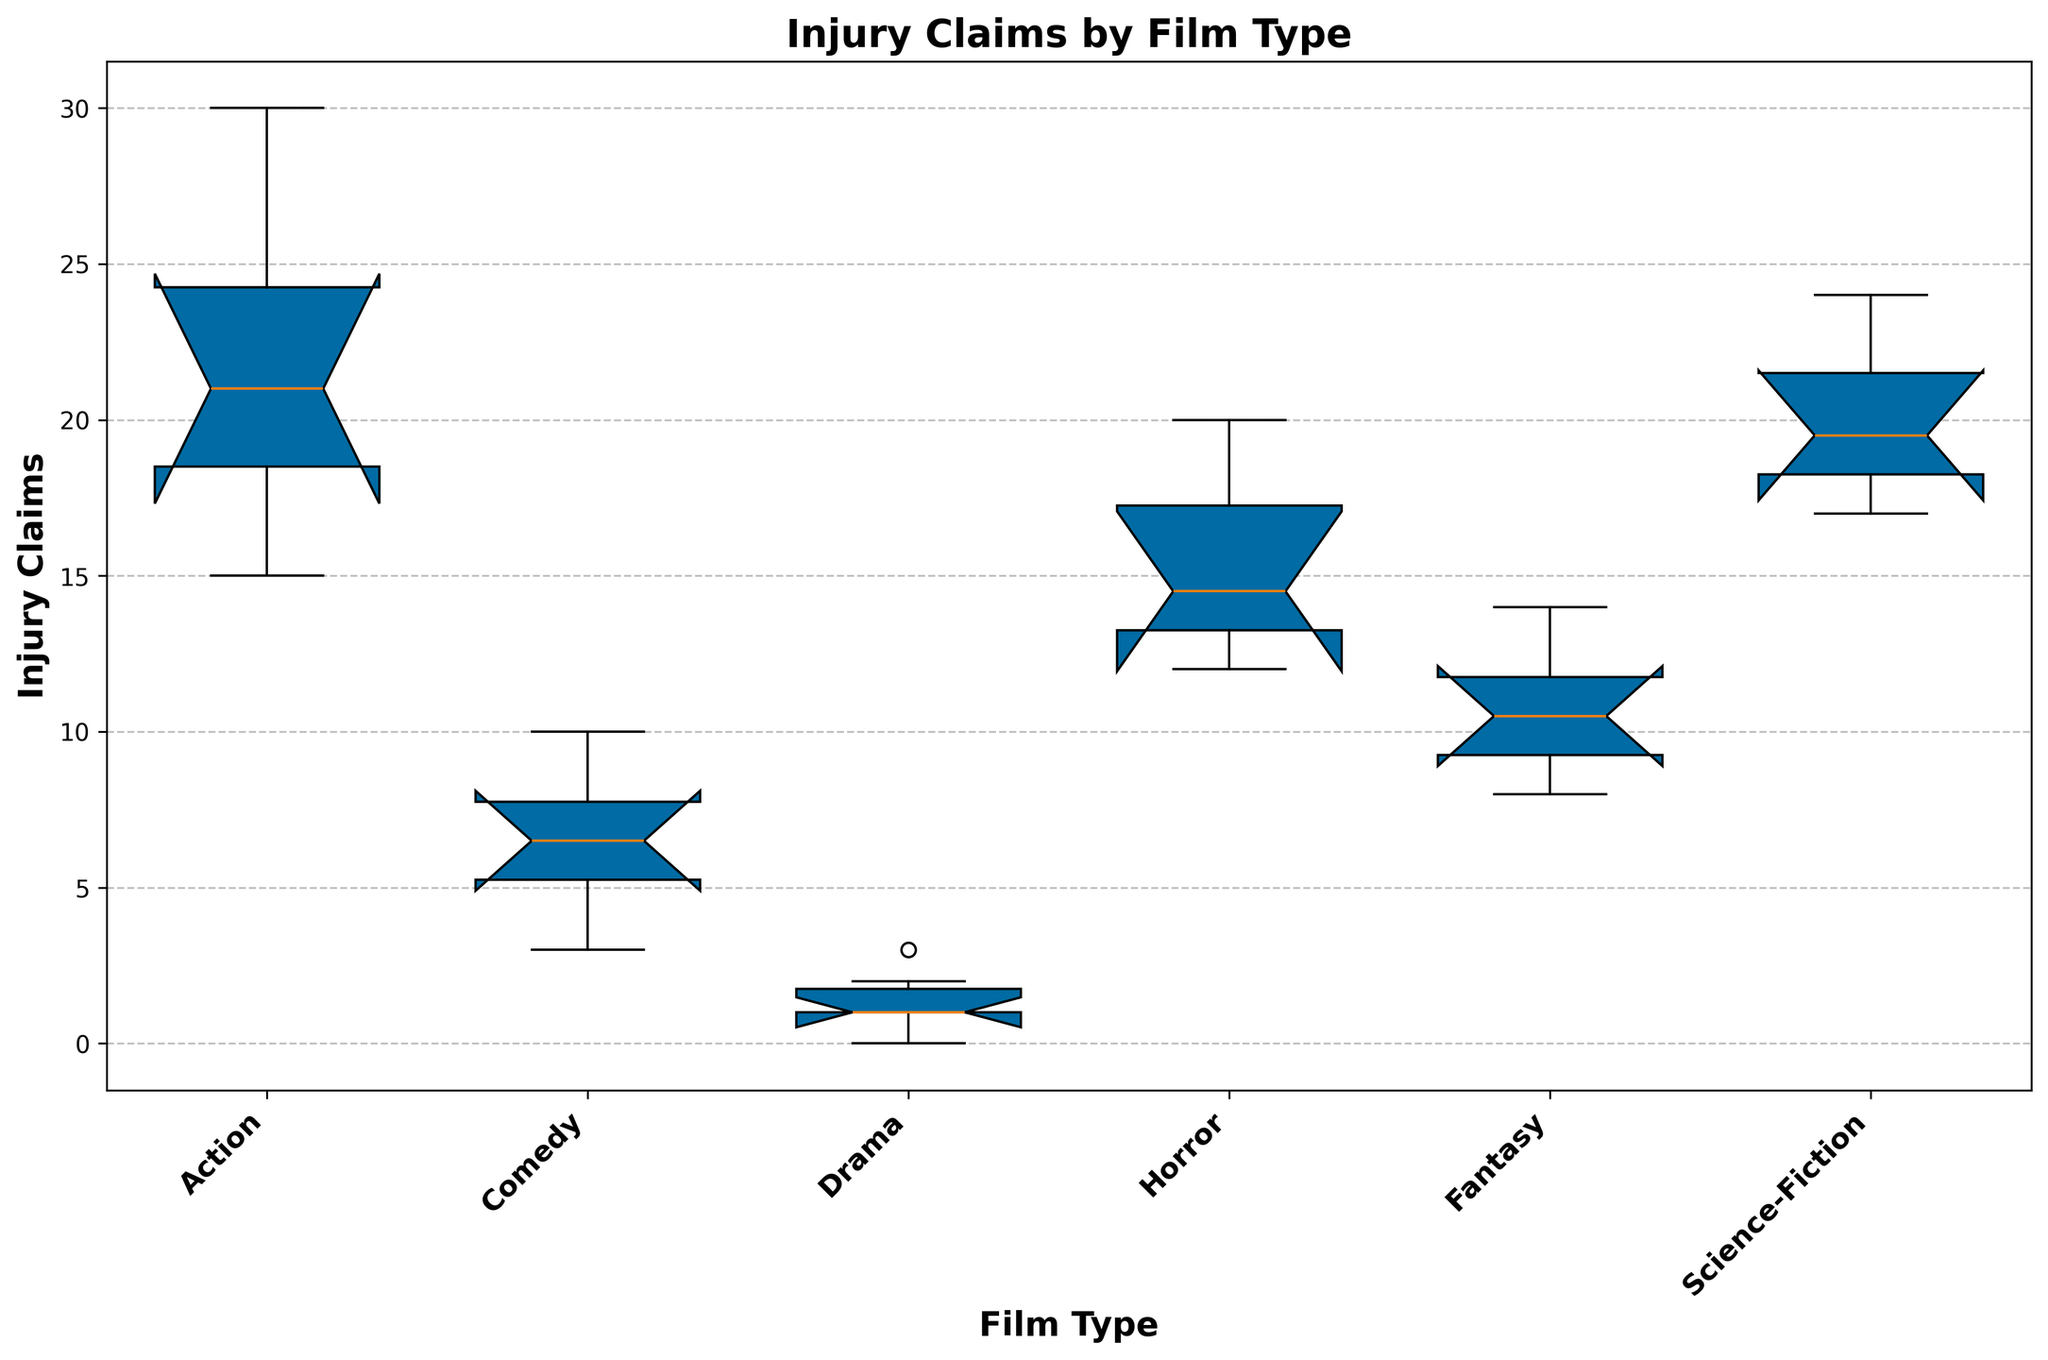what's the median value of Injury Claims for Horror films? To find the median value of Injury Claims for Horror films, look at the middle value when the injury claims data for Horror films is sorted. The values are 12, 13, 14, 15, 18, 20. The median is the average of the two middle values (14 and 15), which is (14+15)/2 = 14.5.
Answer: 14.5 Which film type has the highest median value of injury claims? To answer this, compare the median values of injury claims for all film types. The film type with the highest median is Action, with a median around 20.
Answer: Action Which film type has the lowest median value of injury claims? To determine the film type with the lowest median, look at the box plots and identify the film type with the lowest median line. Drama has the lowest median, with a median around 1.
Answer: Drama How does the interquartile range (IQR) of injury claims for Action films compare to that of Comedy films? To compare the IQR of Action and Comedy films, observe the length of the boxes for each. The IQR of Action films is the distance between the first and third quartiles and is significantly larger than the IQR for Comedy films. Therefore, Action films have a larger IQR for injury claims than Comedy films.
Answer: Larger Are there any outliers in the injury claims data for Science-Fiction films? To identify outliers, look for points that fall outside the whiskers of the box plot for Science-Fiction films. There do not appear to be any distinct outliers beyond the whiskers for Science-Fiction films.
Answer: No Which film type has the widest range of injury claims? To find the film type with the widest range, examine the whiskers (lines extending from the boxes) and pick the one with the longest extension. Action films display the widest range.
Answer: Action Compare the third quartile (Q3) of injury claims between Fantasy and Horror films. The third quartile (Q3) is the top edge of each box. For Fantasy films, Q3 is around 12. For Horror films, Q3 is around 18. Horror films have a higher Q3 than Fantasy films.
Answer: Horror How does the median of Science-Fiction films compare to the first quartile (Q1) for Action films? Find the median of Science-Fiction films, which is around 20, and compare it to the first quartile (Q1) of Action films, which is around 18. The median of Science-Fiction films is higher than the first quartile of Action films.
Answer: Higher In which film type is the variation (spread) of injury claims the smallest? The variation or spread is indicated by the length of the box and whiskers. Drama films show the smallest variation, with a box and whiskers that are closely packed together.
Answer: Drama 